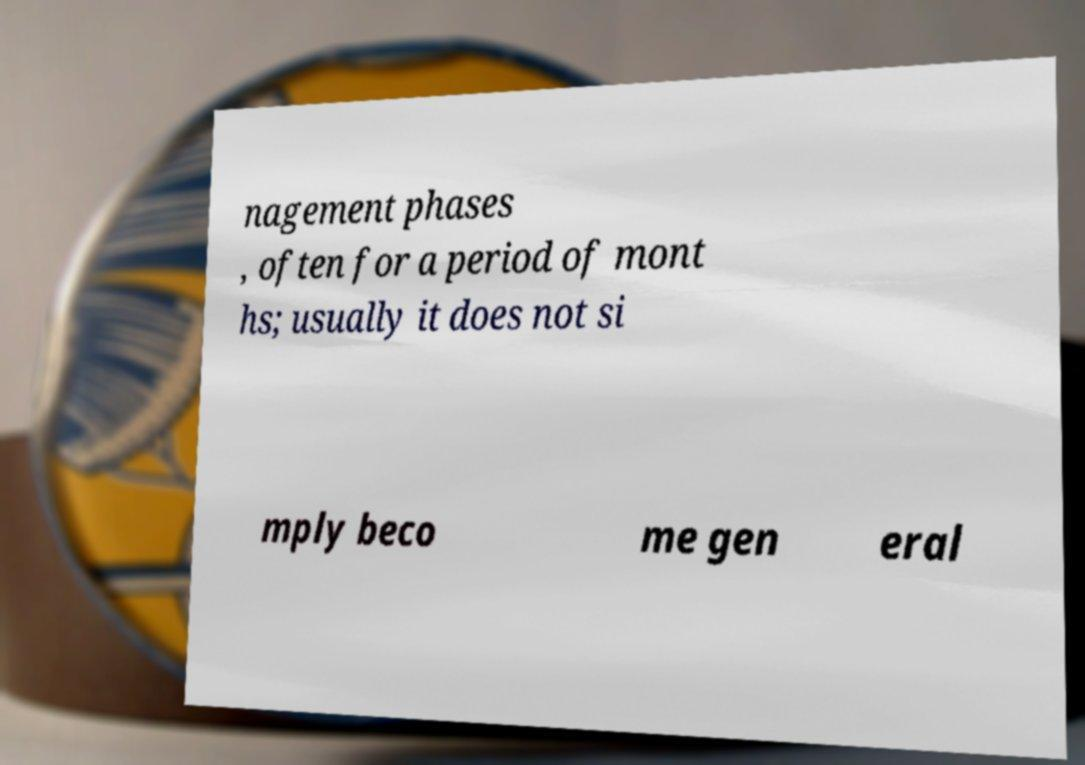Can you accurately transcribe the text from the provided image for me? nagement phases , often for a period of mont hs; usually it does not si mply beco me gen eral 